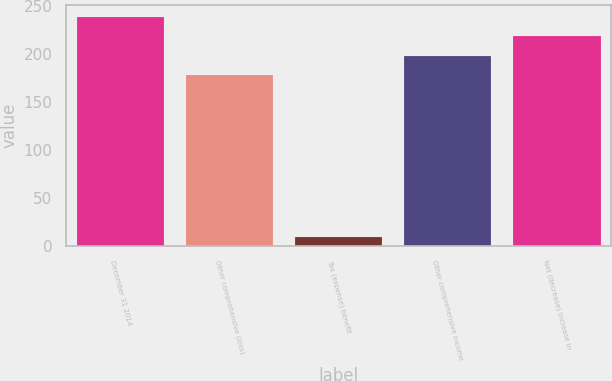Convert chart. <chart><loc_0><loc_0><loc_500><loc_500><bar_chart><fcel>December 31 2014<fcel>Other comprehensive (loss)<fcel>Tax (expense) benefit<fcel>Other comprehensive income<fcel>Net (decrease) increase in<nl><fcel>238.9<fcel>178<fcel>9.5<fcel>198.3<fcel>218.6<nl></chart> 